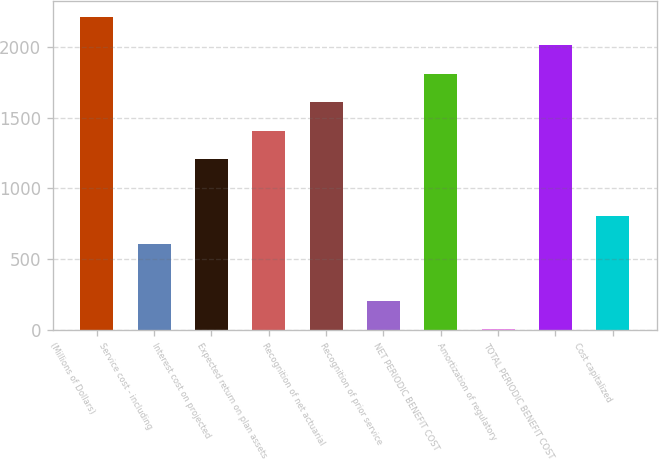Convert chart. <chart><loc_0><loc_0><loc_500><loc_500><bar_chart><fcel>(Millions of Dollars)<fcel>Service cost - including<fcel>Interest cost on projected<fcel>Expected return on plan assets<fcel>Recognition of net actuarial<fcel>Recognition of prior service<fcel>NET PERIODIC BENEFIT COST<fcel>Amortization of regulatory<fcel>TOTAL PERIODIC BENEFIT COST<fcel>Cost capitalized<nl><fcel>2214.1<fcel>605.3<fcel>1208.6<fcel>1409.7<fcel>1610.8<fcel>203.1<fcel>1811.9<fcel>2<fcel>2013<fcel>806.4<nl></chart> 